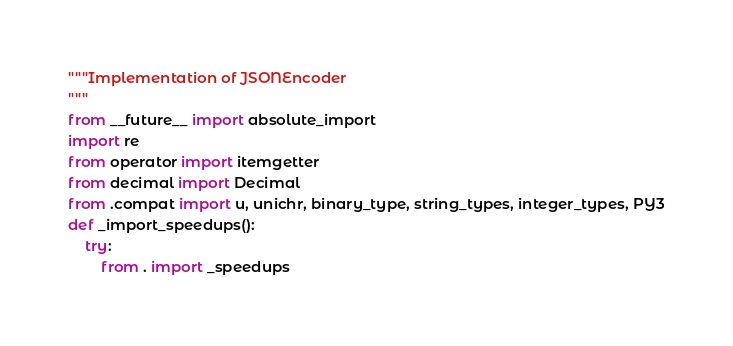Convert code to text. <code><loc_0><loc_0><loc_500><loc_500><_Python_>"""Implementation of JSONEncoder
"""
from __future__ import absolute_import
import re
from operator import itemgetter
from decimal import Decimal
from .compat import u, unichr, binary_type, string_types, integer_types, PY3
def _import_speedups():
    try:
        from . import _speedups</code> 